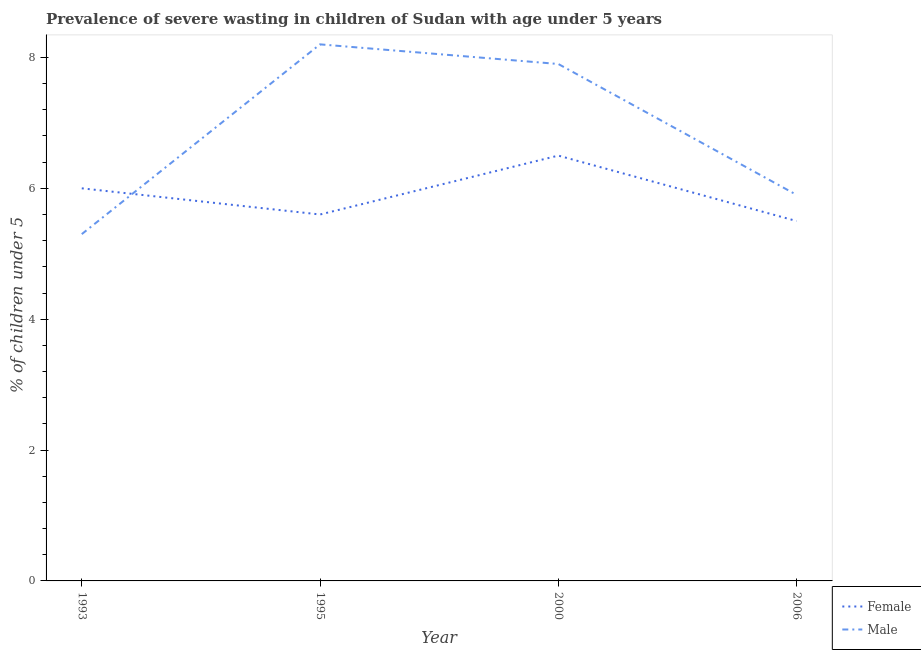What is the percentage of undernourished male children in 2000?
Offer a very short reply. 7.9. Across all years, what is the maximum percentage of undernourished male children?
Your answer should be very brief. 8.2. In which year was the percentage of undernourished female children maximum?
Your answer should be very brief. 2000. What is the total percentage of undernourished male children in the graph?
Offer a very short reply. 27.3. What is the difference between the percentage of undernourished female children in 1993 and that in 2006?
Offer a very short reply. 0.5. What is the difference between the percentage of undernourished female children in 2006 and the percentage of undernourished male children in 1995?
Keep it short and to the point. -2.7. What is the average percentage of undernourished female children per year?
Ensure brevity in your answer.  5.9. In the year 2000, what is the difference between the percentage of undernourished female children and percentage of undernourished male children?
Your response must be concise. -1.4. What is the ratio of the percentage of undernourished male children in 1993 to that in 2006?
Ensure brevity in your answer.  0.9. Is the percentage of undernourished male children in 1993 less than that in 2000?
Keep it short and to the point. Yes. What is the difference between the highest and the second highest percentage of undernourished female children?
Make the answer very short. 0.5. Does the percentage of undernourished female children monotonically increase over the years?
Make the answer very short. No. Is the percentage of undernourished male children strictly greater than the percentage of undernourished female children over the years?
Ensure brevity in your answer.  No. Is the percentage of undernourished female children strictly less than the percentage of undernourished male children over the years?
Provide a short and direct response. No. How many years are there in the graph?
Provide a succinct answer. 4. Does the graph contain any zero values?
Keep it short and to the point. No. Where does the legend appear in the graph?
Give a very brief answer. Bottom right. How many legend labels are there?
Offer a terse response. 2. How are the legend labels stacked?
Your response must be concise. Vertical. What is the title of the graph?
Keep it short and to the point. Prevalence of severe wasting in children of Sudan with age under 5 years. What is the label or title of the Y-axis?
Offer a terse response.  % of children under 5. What is the  % of children under 5 in Female in 1993?
Make the answer very short. 6. What is the  % of children under 5 in Male in 1993?
Provide a succinct answer. 5.3. What is the  % of children under 5 in Female in 1995?
Make the answer very short. 5.6. What is the  % of children under 5 of Male in 1995?
Keep it short and to the point. 8.2. What is the  % of children under 5 of Male in 2000?
Give a very brief answer. 7.9. What is the  % of children under 5 of Female in 2006?
Ensure brevity in your answer.  5.5. What is the  % of children under 5 in Male in 2006?
Provide a succinct answer. 5.9. Across all years, what is the maximum  % of children under 5 in Female?
Provide a short and direct response. 6.5. Across all years, what is the maximum  % of children under 5 of Male?
Offer a very short reply. 8.2. Across all years, what is the minimum  % of children under 5 of Male?
Offer a terse response. 5.3. What is the total  % of children under 5 of Female in the graph?
Your answer should be very brief. 23.6. What is the total  % of children under 5 of Male in the graph?
Offer a very short reply. 27.3. What is the difference between the  % of children under 5 in Female in 1993 and that in 1995?
Give a very brief answer. 0.4. What is the difference between the  % of children under 5 of Male in 1993 and that in 1995?
Give a very brief answer. -2.9. What is the difference between the  % of children under 5 in Female in 1993 and that in 2000?
Your answer should be compact. -0.5. What is the difference between the  % of children under 5 in Male in 1993 and that in 2000?
Offer a terse response. -2.6. What is the difference between the  % of children under 5 of Male in 1993 and that in 2006?
Give a very brief answer. -0.6. What is the difference between the  % of children under 5 of Female in 1995 and that in 2000?
Keep it short and to the point. -0.9. What is the difference between the  % of children under 5 of Female in 1995 and that in 2006?
Give a very brief answer. 0.1. What is the difference between the  % of children under 5 of Female in 1993 and the  % of children under 5 of Male in 1995?
Your answer should be very brief. -2.2. What is the difference between the  % of children under 5 in Female in 1993 and the  % of children under 5 in Male in 2000?
Your answer should be very brief. -1.9. What is the average  % of children under 5 of Male per year?
Provide a succinct answer. 6.83. In the year 2000, what is the difference between the  % of children under 5 of Female and  % of children under 5 of Male?
Offer a very short reply. -1.4. What is the ratio of the  % of children under 5 of Female in 1993 to that in 1995?
Provide a succinct answer. 1.07. What is the ratio of the  % of children under 5 of Male in 1993 to that in 1995?
Provide a succinct answer. 0.65. What is the ratio of the  % of children under 5 of Male in 1993 to that in 2000?
Provide a succinct answer. 0.67. What is the ratio of the  % of children under 5 of Female in 1993 to that in 2006?
Provide a short and direct response. 1.09. What is the ratio of the  % of children under 5 of Male in 1993 to that in 2006?
Your response must be concise. 0.9. What is the ratio of the  % of children under 5 of Female in 1995 to that in 2000?
Offer a very short reply. 0.86. What is the ratio of the  % of children under 5 of Male in 1995 to that in 2000?
Keep it short and to the point. 1.04. What is the ratio of the  % of children under 5 of Female in 1995 to that in 2006?
Offer a very short reply. 1.02. What is the ratio of the  % of children under 5 in Male in 1995 to that in 2006?
Offer a terse response. 1.39. What is the ratio of the  % of children under 5 of Female in 2000 to that in 2006?
Provide a succinct answer. 1.18. What is the ratio of the  % of children under 5 of Male in 2000 to that in 2006?
Your answer should be very brief. 1.34. What is the difference between the highest and the second highest  % of children under 5 in Female?
Your response must be concise. 0.5. What is the difference between the highest and the second highest  % of children under 5 of Male?
Your answer should be compact. 0.3. What is the difference between the highest and the lowest  % of children under 5 of Female?
Ensure brevity in your answer.  1. What is the difference between the highest and the lowest  % of children under 5 of Male?
Offer a very short reply. 2.9. 